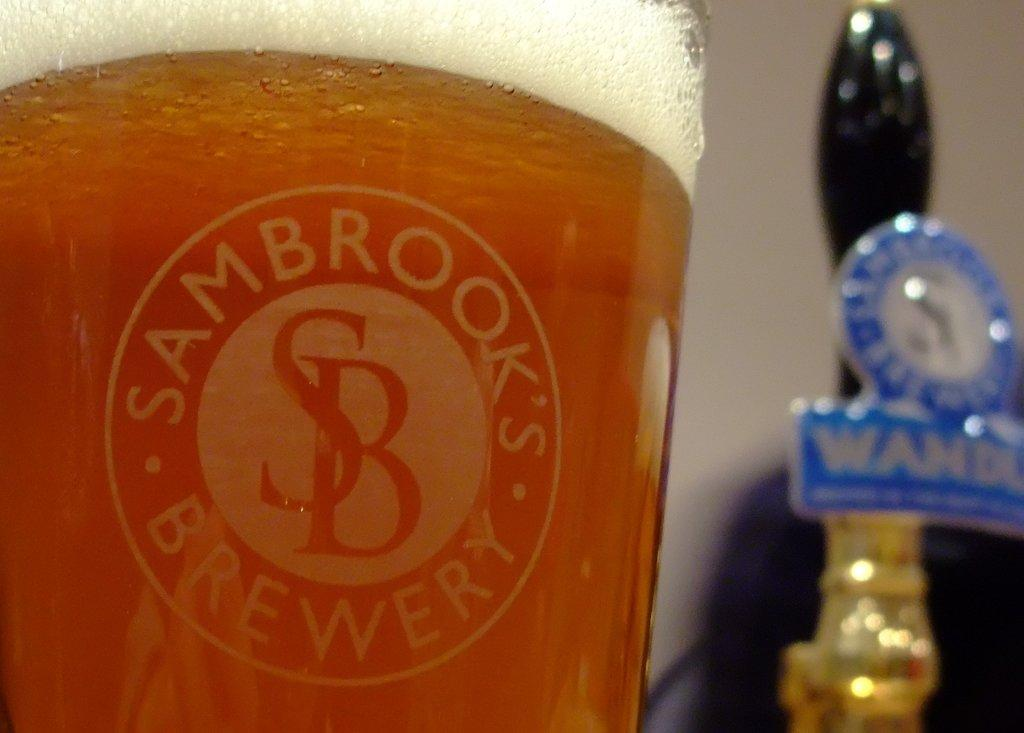<image>
Create a compact narrative representing the image presented. A beer in a pint glass from Sambrooks Brewery. 